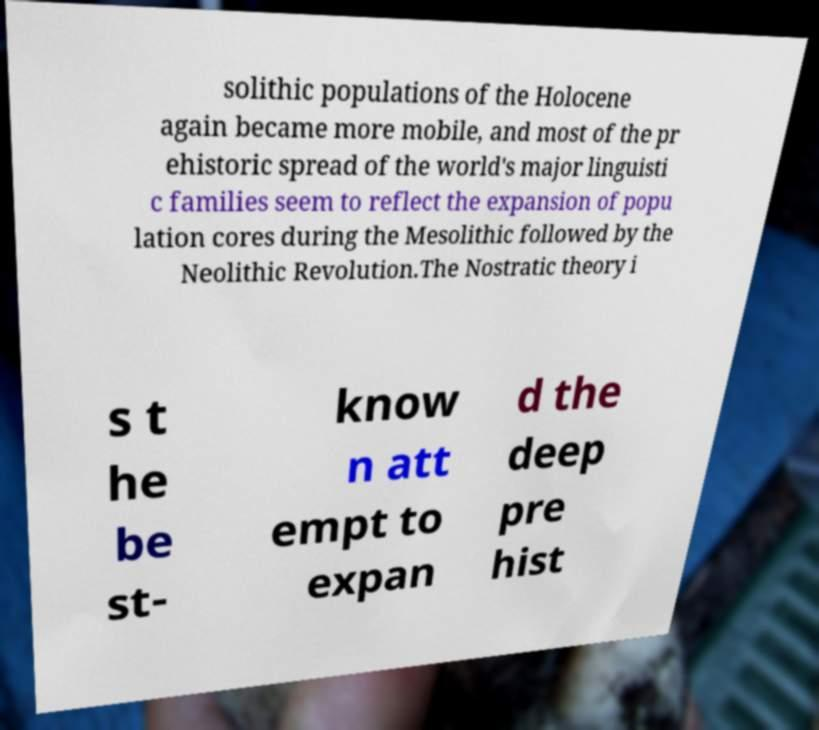I need the written content from this picture converted into text. Can you do that? solithic populations of the Holocene again became more mobile, and most of the pr ehistoric spread of the world's major linguisti c families seem to reflect the expansion of popu lation cores during the Mesolithic followed by the Neolithic Revolution.The Nostratic theory i s t he be st- know n att empt to expan d the deep pre hist 